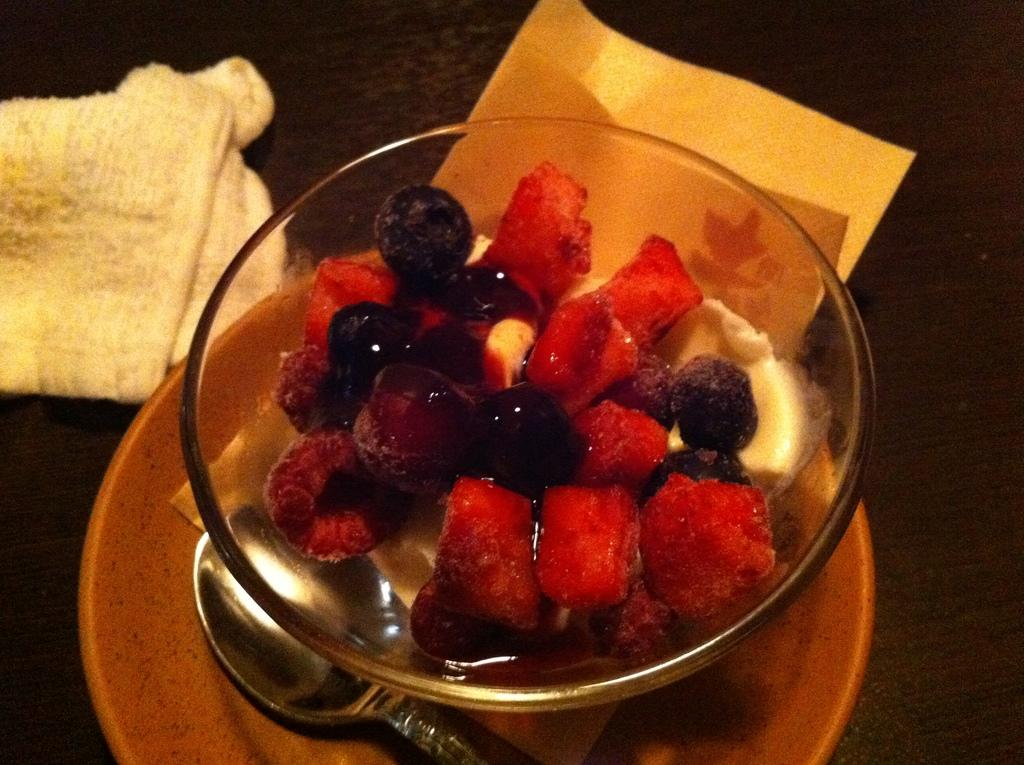What is the primary color of the surface in the image? The primary color of the surface in the image is black. What items can be seen on the black surface? There is a towel, a paper, a saucer, a spoon, and a bowl with fruits on the black surface. What is the purpose of the saucer in the image? The saucer is used to hold the bowl with fruits and some sauce. What type of utensil is on the saucer? There is a spoon on the saucer. What advice does the mint leaf on the black surface give to the spoon? There is no mint leaf present in the image, and therefore no advice can be given. 